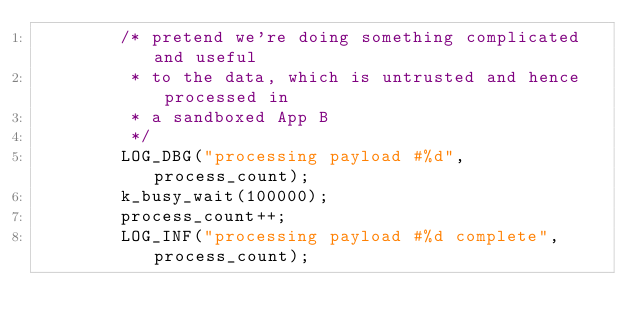Convert code to text. <code><loc_0><loc_0><loc_500><loc_500><_C_>		/* pretend we're doing something complicated and useful
		 * to the data, which is untrusted and hence processed in
		 * a sandboxed App B
		 */
		LOG_DBG("processing payload #%d", process_count);
		k_busy_wait(100000);
		process_count++;
		LOG_INF("processing payload #%d complete", process_count);
</code> 